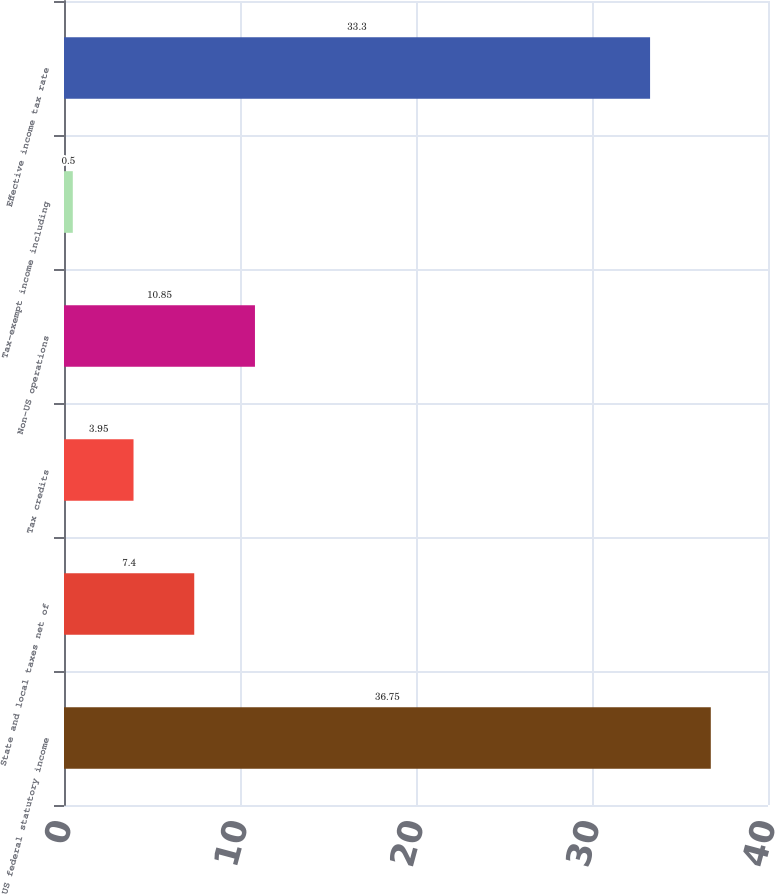Convert chart to OTSL. <chart><loc_0><loc_0><loc_500><loc_500><bar_chart><fcel>US federal statutory income<fcel>State and local taxes net of<fcel>Tax credits<fcel>Non-US operations<fcel>Tax-exempt income including<fcel>Effective income tax rate<nl><fcel>36.75<fcel>7.4<fcel>3.95<fcel>10.85<fcel>0.5<fcel>33.3<nl></chart> 